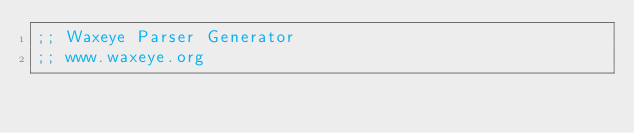<code> <loc_0><loc_0><loc_500><loc_500><_Scheme_>;; Waxeye Parser Generator
;; www.waxeye.org</code> 